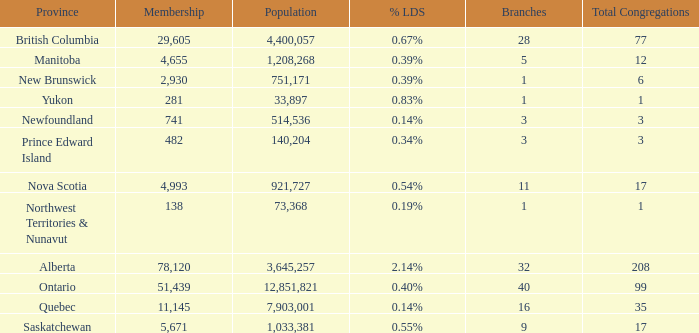What's the fewest number of branches with more than 1 total congregations, a population of 1,033,381, and a membership smaller than 5,671? None. 